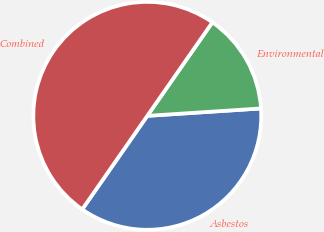Convert chart to OTSL. <chart><loc_0><loc_0><loc_500><loc_500><pie_chart><fcel>Asbestos<fcel>Environmental<fcel>Combined<nl><fcel>35.71%<fcel>14.29%<fcel>50.0%<nl></chart> 